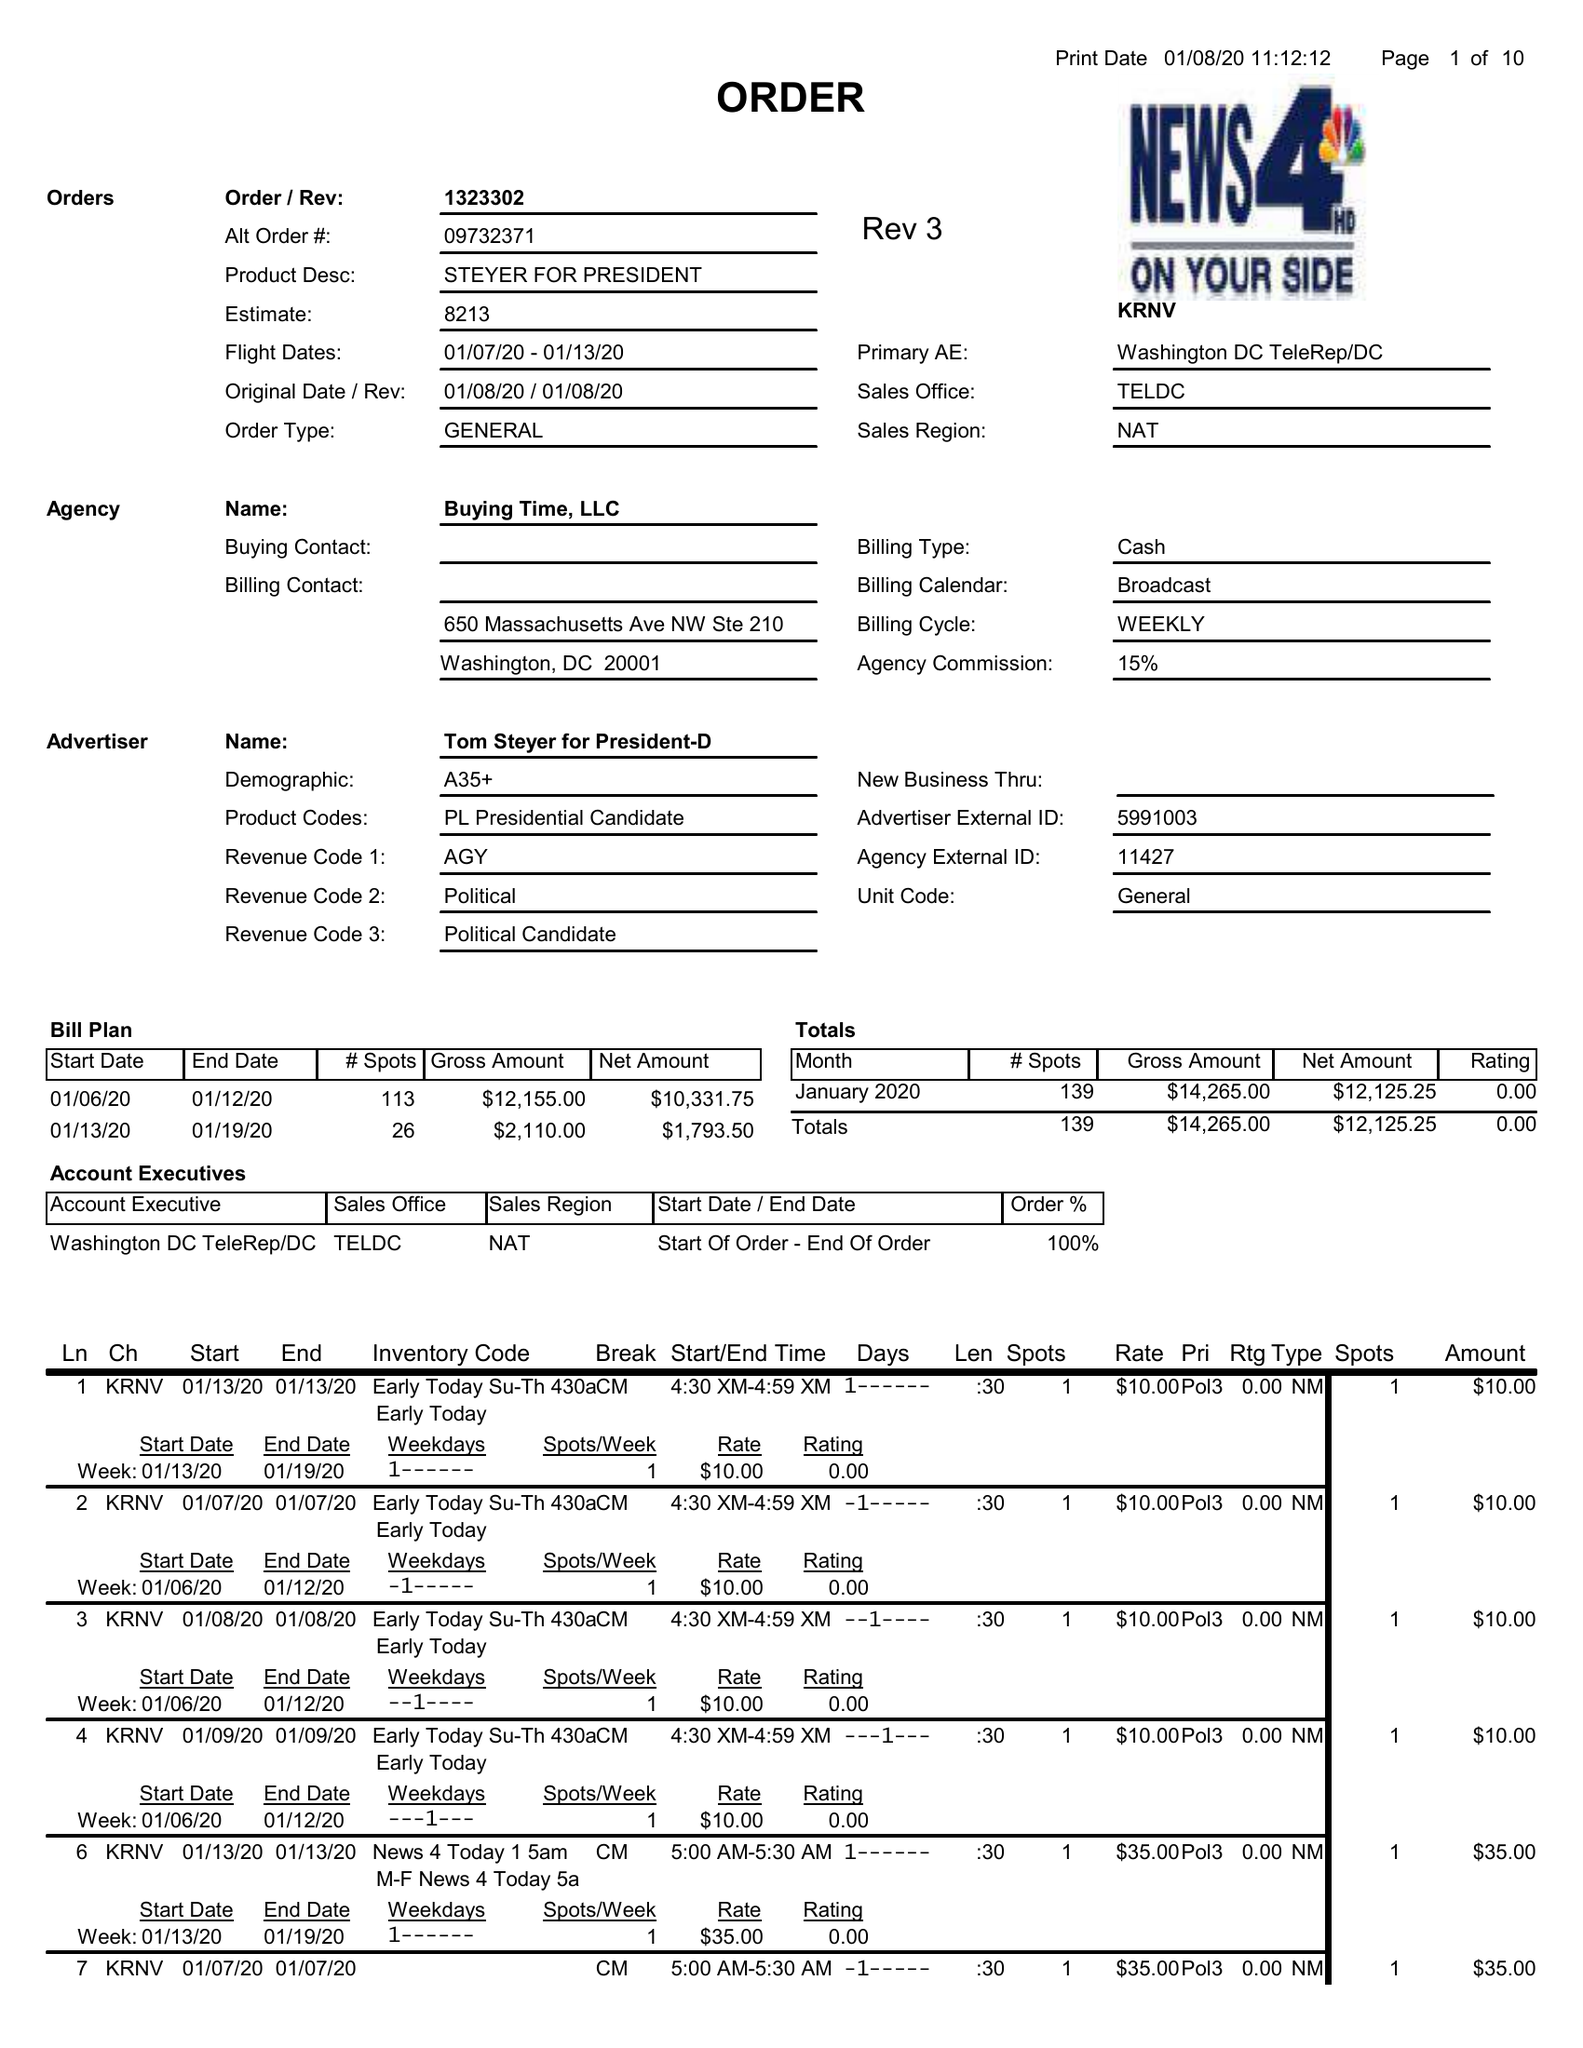What is the value for the flight_from?
Answer the question using a single word or phrase. 01/07/20 